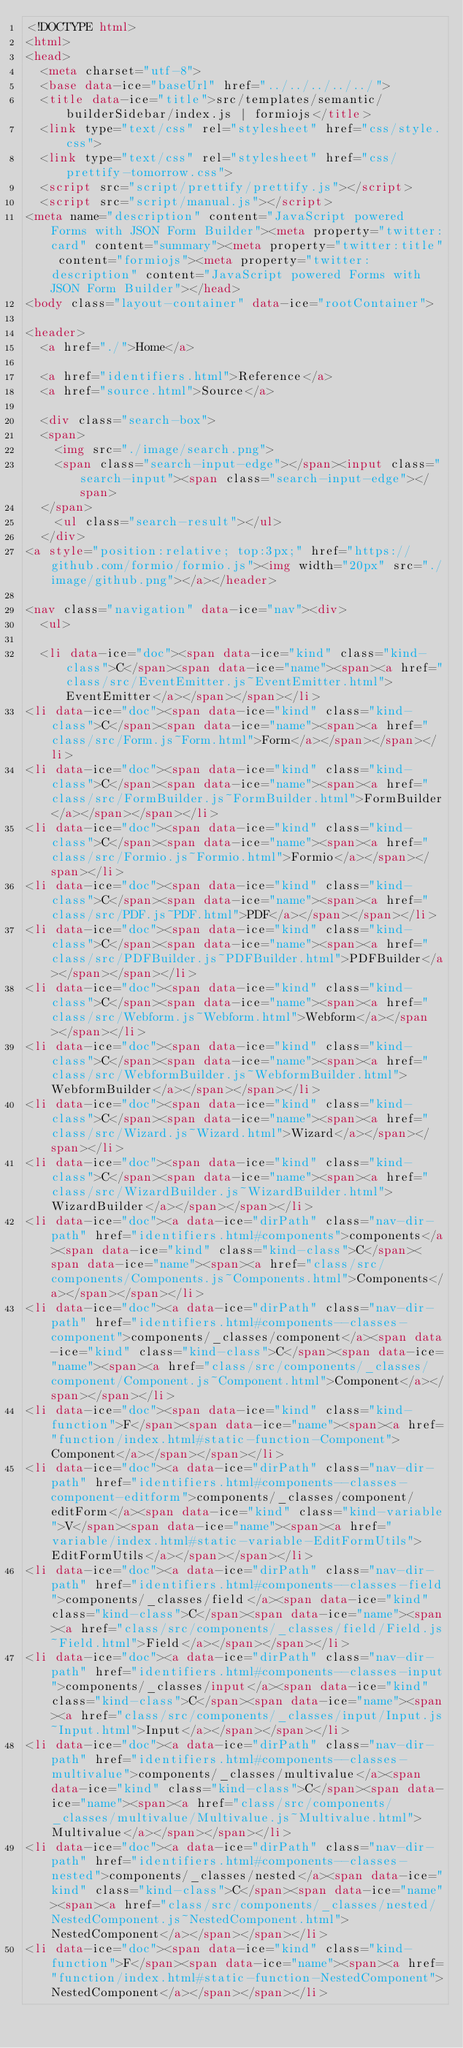Convert code to text. <code><loc_0><loc_0><loc_500><loc_500><_HTML_><!DOCTYPE html>
<html>
<head>
  <meta charset="utf-8">
  <base data-ice="baseUrl" href="../../../../../">
  <title data-ice="title">src/templates/semantic/builderSidebar/index.js | formiojs</title>
  <link type="text/css" rel="stylesheet" href="css/style.css">
  <link type="text/css" rel="stylesheet" href="css/prettify-tomorrow.css">
  <script src="script/prettify/prettify.js"></script>
  <script src="script/manual.js"></script>
<meta name="description" content="JavaScript powered Forms with JSON Form Builder"><meta property="twitter:card" content="summary"><meta property="twitter:title" content="formiojs"><meta property="twitter:description" content="JavaScript powered Forms with JSON Form Builder"></head>
<body class="layout-container" data-ice="rootContainer">

<header>
  <a href="./">Home</a>
  
  <a href="identifiers.html">Reference</a>
  <a href="source.html">Source</a>
  
  <div class="search-box">
  <span>
    <img src="./image/search.png">
    <span class="search-input-edge"></span><input class="search-input"><span class="search-input-edge"></span>
  </span>
    <ul class="search-result"></ul>
  </div>
<a style="position:relative; top:3px;" href="https://github.com/formio/formio.js"><img width="20px" src="./image/github.png"></a></header>

<nav class="navigation" data-ice="nav"><div>
  <ul>
    
  <li data-ice="doc"><span data-ice="kind" class="kind-class">C</span><span data-ice="name"><span><a href="class/src/EventEmitter.js~EventEmitter.html">EventEmitter</a></span></span></li>
<li data-ice="doc"><span data-ice="kind" class="kind-class">C</span><span data-ice="name"><span><a href="class/src/Form.js~Form.html">Form</a></span></span></li>
<li data-ice="doc"><span data-ice="kind" class="kind-class">C</span><span data-ice="name"><span><a href="class/src/FormBuilder.js~FormBuilder.html">FormBuilder</a></span></span></li>
<li data-ice="doc"><span data-ice="kind" class="kind-class">C</span><span data-ice="name"><span><a href="class/src/Formio.js~Formio.html">Formio</a></span></span></li>
<li data-ice="doc"><span data-ice="kind" class="kind-class">C</span><span data-ice="name"><span><a href="class/src/PDF.js~PDF.html">PDF</a></span></span></li>
<li data-ice="doc"><span data-ice="kind" class="kind-class">C</span><span data-ice="name"><span><a href="class/src/PDFBuilder.js~PDFBuilder.html">PDFBuilder</a></span></span></li>
<li data-ice="doc"><span data-ice="kind" class="kind-class">C</span><span data-ice="name"><span><a href="class/src/Webform.js~Webform.html">Webform</a></span></span></li>
<li data-ice="doc"><span data-ice="kind" class="kind-class">C</span><span data-ice="name"><span><a href="class/src/WebformBuilder.js~WebformBuilder.html">WebformBuilder</a></span></span></li>
<li data-ice="doc"><span data-ice="kind" class="kind-class">C</span><span data-ice="name"><span><a href="class/src/Wizard.js~Wizard.html">Wizard</a></span></span></li>
<li data-ice="doc"><span data-ice="kind" class="kind-class">C</span><span data-ice="name"><span><a href="class/src/WizardBuilder.js~WizardBuilder.html">WizardBuilder</a></span></span></li>
<li data-ice="doc"><a data-ice="dirPath" class="nav-dir-path" href="identifiers.html#components">components</a><span data-ice="kind" class="kind-class">C</span><span data-ice="name"><span><a href="class/src/components/Components.js~Components.html">Components</a></span></span></li>
<li data-ice="doc"><a data-ice="dirPath" class="nav-dir-path" href="identifiers.html#components--classes-component">components/_classes/component</a><span data-ice="kind" class="kind-class">C</span><span data-ice="name"><span><a href="class/src/components/_classes/component/Component.js~Component.html">Component</a></span></span></li>
<li data-ice="doc"><span data-ice="kind" class="kind-function">F</span><span data-ice="name"><span><a href="function/index.html#static-function-Component">Component</a></span></span></li>
<li data-ice="doc"><a data-ice="dirPath" class="nav-dir-path" href="identifiers.html#components--classes-component-editform">components/_classes/component/editForm</a><span data-ice="kind" class="kind-variable">V</span><span data-ice="name"><span><a href="variable/index.html#static-variable-EditFormUtils">EditFormUtils</a></span></span></li>
<li data-ice="doc"><a data-ice="dirPath" class="nav-dir-path" href="identifiers.html#components--classes-field">components/_classes/field</a><span data-ice="kind" class="kind-class">C</span><span data-ice="name"><span><a href="class/src/components/_classes/field/Field.js~Field.html">Field</a></span></span></li>
<li data-ice="doc"><a data-ice="dirPath" class="nav-dir-path" href="identifiers.html#components--classes-input">components/_classes/input</a><span data-ice="kind" class="kind-class">C</span><span data-ice="name"><span><a href="class/src/components/_classes/input/Input.js~Input.html">Input</a></span></span></li>
<li data-ice="doc"><a data-ice="dirPath" class="nav-dir-path" href="identifiers.html#components--classes-multivalue">components/_classes/multivalue</a><span data-ice="kind" class="kind-class">C</span><span data-ice="name"><span><a href="class/src/components/_classes/multivalue/Multivalue.js~Multivalue.html">Multivalue</a></span></span></li>
<li data-ice="doc"><a data-ice="dirPath" class="nav-dir-path" href="identifiers.html#components--classes-nested">components/_classes/nested</a><span data-ice="kind" class="kind-class">C</span><span data-ice="name"><span><a href="class/src/components/_classes/nested/NestedComponent.js~NestedComponent.html">NestedComponent</a></span></span></li>
<li data-ice="doc"><span data-ice="kind" class="kind-function">F</span><span data-ice="name"><span><a href="function/index.html#static-function-NestedComponent">NestedComponent</a></span></span></li></code> 